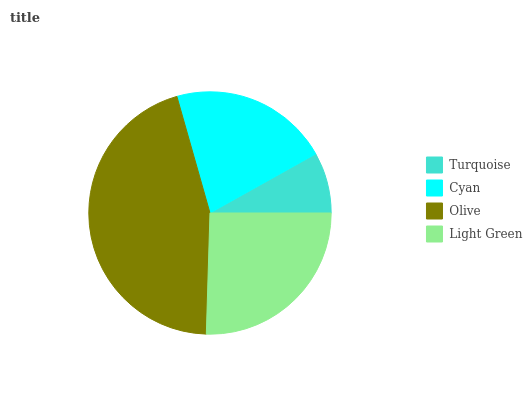Is Turquoise the minimum?
Answer yes or no. Yes. Is Olive the maximum?
Answer yes or no. Yes. Is Cyan the minimum?
Answer yes or no. No. Is Cyan the maximum?
Answer yes or no. No. Is Cyan greater than Turquoise?
Answer yes or no. Yes. Is Turquoise less than Cyan?
Answer yes or no. Yes. Is Turquoise greater than Cyan?
Answer yes or no. No. Is Cyan less than Turquoise?
Answer yes or no. No. Is Light Green the high median?
Answer yes or no. Yes. Is Cyan the low median?
Answer yes or no. Yes. Is Olive the high median?
Answer yes or no. No. Is Turquoise the low median?
Answer yes or no. No. 